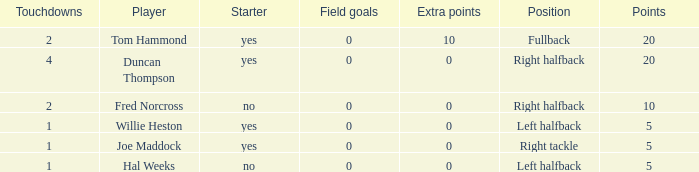What is the highest field goals when there were more than 1 touchdown and 0 extra points? 0.0. 